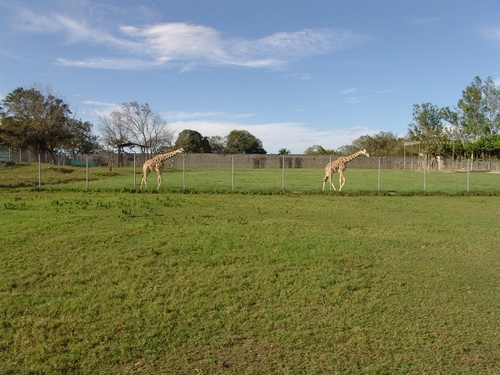Describe the objects in this image and their specific colors. I can see giraffe in darkgray, tan, olive, and gray tones and giraffe in darkgray, tan, and olive tones in this image. 